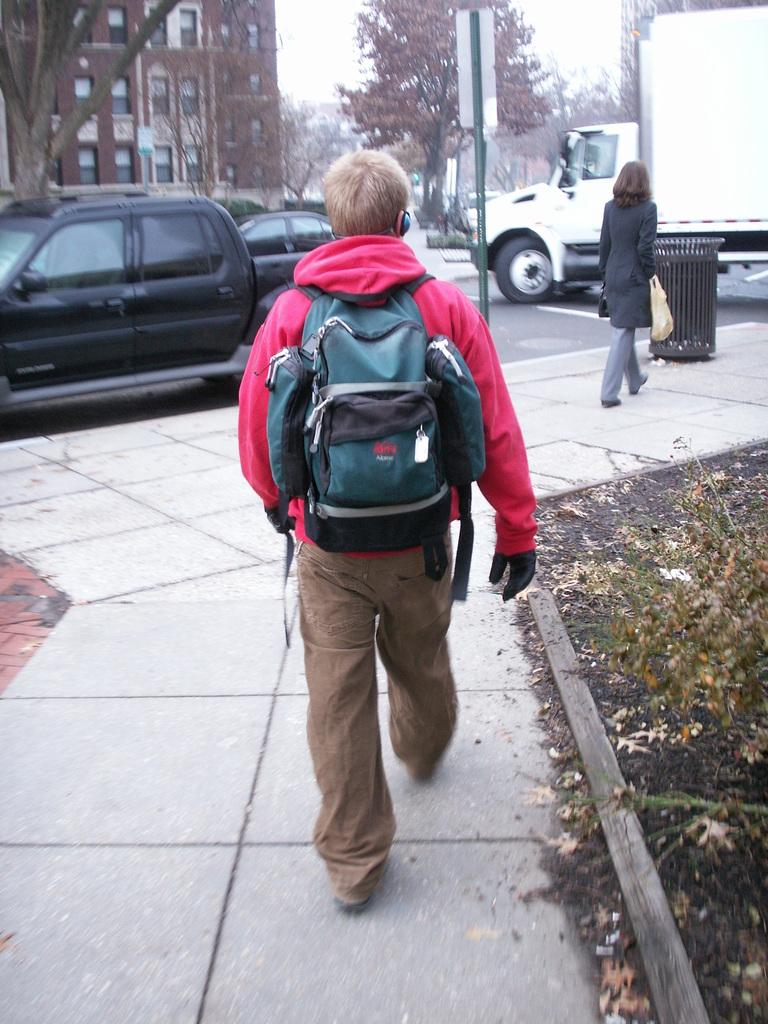What type of structure is visible in the image? There is a building in the image. What natural elements can be seen in the image? There are trees in the image. What vehicles are present in the image? There are cars and a truck in the image. What activity are two people engaged in within the image? Two people are walking on the road in the image. Where is the shop located in the image? There is no shop present in the image. What type of education is being provided in the image? There is no indication of any educational activity in the image. 